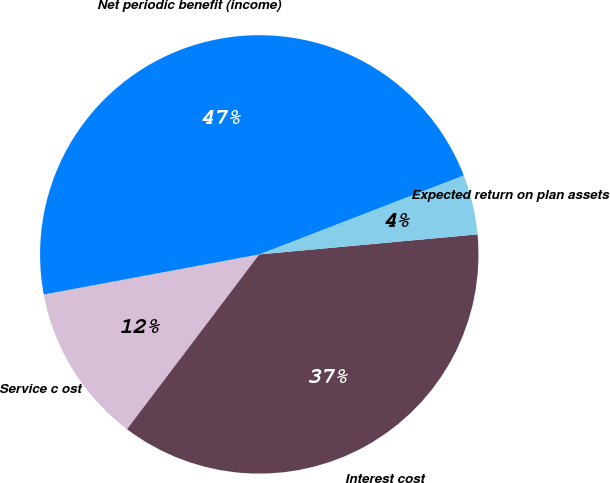Convert chart to OTSL. <chart><loc_0><loc_0><loc_500><loc_500><pie_chart><fcel>Service c ost<fcel>Interest cost<fcel>Expected return on plan assets<fcel>Net periodic benefit (income)<nl><fcel>11.76%<fcel>36.76%<fcel>4.41%<fcel>47.06%<nl></chart> 